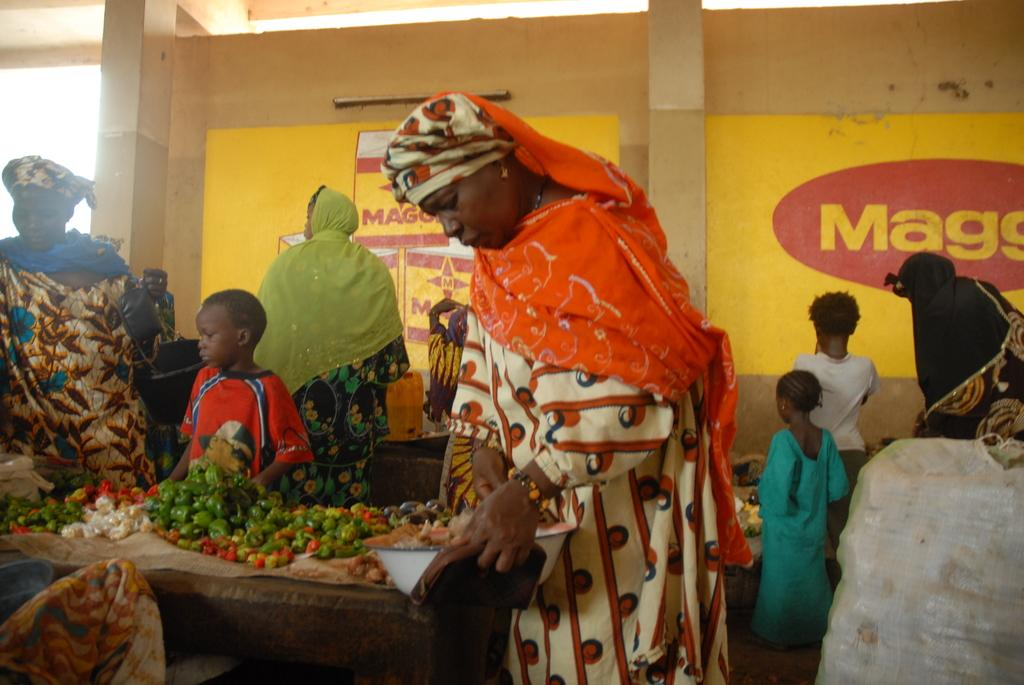Who is present in the image? There are people in the image. What are the people doing in the image? The people are standing around a table. What is on the table in the image? There are vegetables on the table. What else can be seen in the image besides the people and the table? There is a poster visible in the image. What type of art trail can be seen in the image? There is no art trail present in the image; it features people standing around a table with vegetables and a poster. What division of labor is depicted in the image? There is no division of labor depicted in the image; it simply shows people standing around a table with vegetables and a poster. 